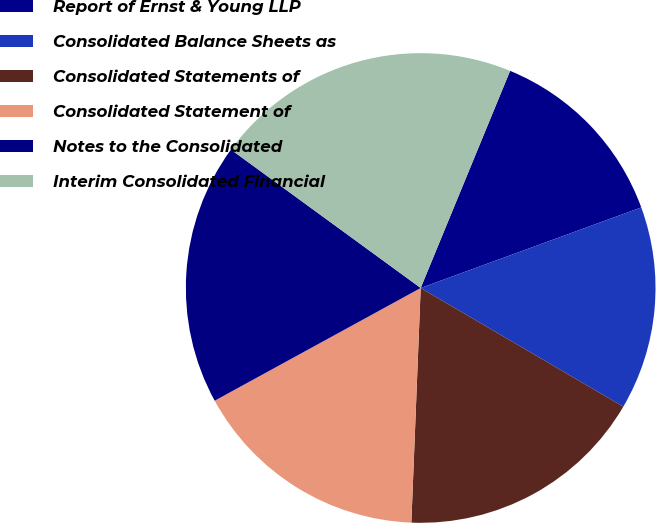<chart> <loc_0><loc_0><loc_500><loc_500><pie_chart><fcel>Report of Ernst & Young LLP<fcel>Consolidated Balance Sheets as<fcel>Consolidated Statements of<fcel>Consolidated Statement of<fcel>Notes to the Consolidated<fcel>Interim Consolidated Financial<nl><fcel>13.21%<fcel>14.01%<fcel>17.2%<fcel>16.4%<fcel>18.0%<fcel>21.19%<nl></chart> 